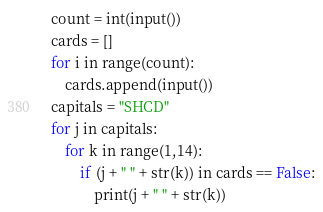Convert code to text. <code><loc_0><loc_0><loc_500><loc_500><_Python_>count = int(input())
cards = []
for i in range(count):
    cards.append(input())
capitals = "SHCD"
for j in capitals:
    for k in range(1,14):
        if (j + " " + str(k)) in cards == False:
            print(j + " " + str(k))
</code> 